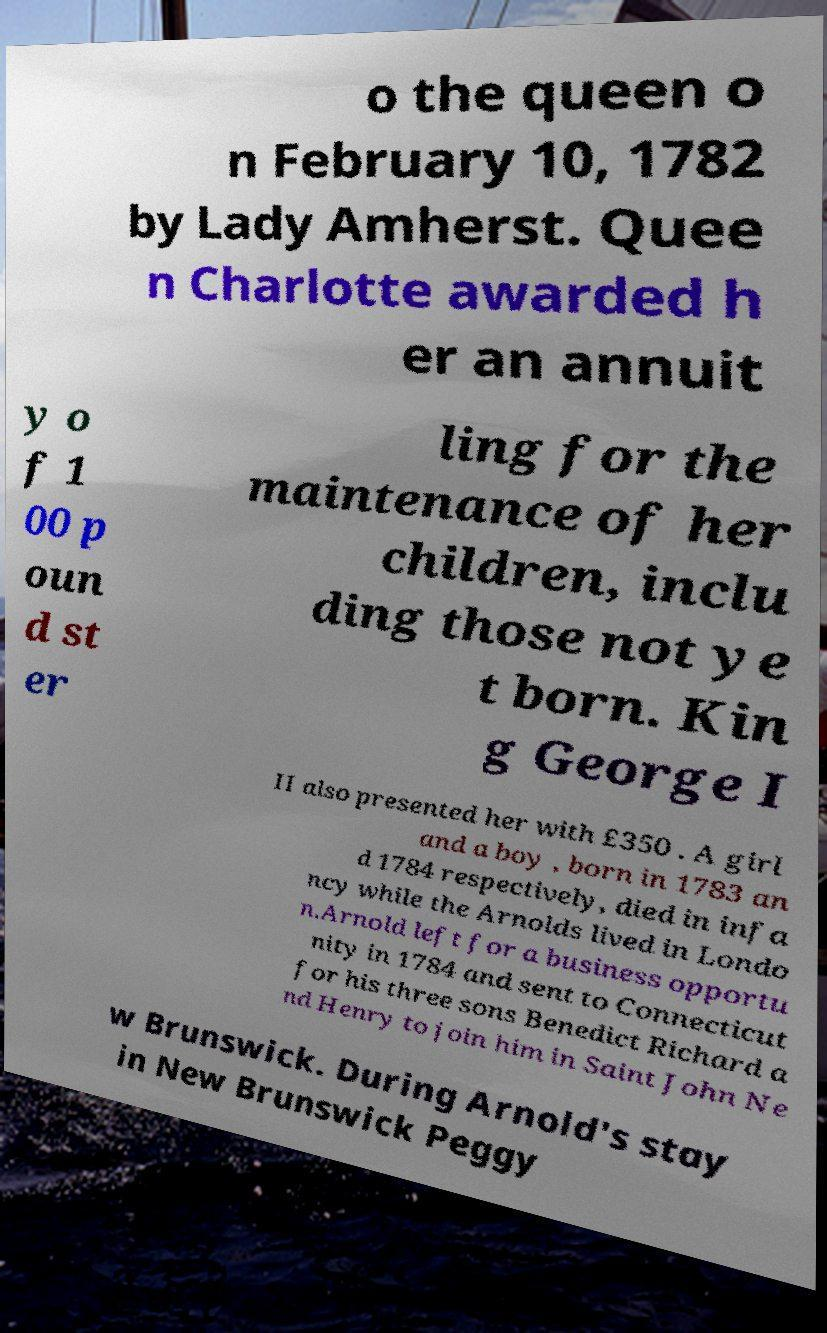What messages or text are displayed in this image? I need them in a readable, typed format. o the queen o n February 10, 1782 by Lady Amherst. Quee n Charlotte awarded h er an annuit y o f 1 00 p oun d st er ling for the maintenance of her children, inclu ding those not ye t born. Kin g George I II also presented her with £350 . A girl and a boy , born in 1783 an d 1784 respectively, died in infa ncy while the Arnolds lived in Londo n.Arnold left for a business opportu nity in 1784 and sent to Connecticut for his three sons Benedict Richard a nd Henry to join him in Saint John Ne w Brunswick. During Arnold's stay in New Brunswick Peggy 